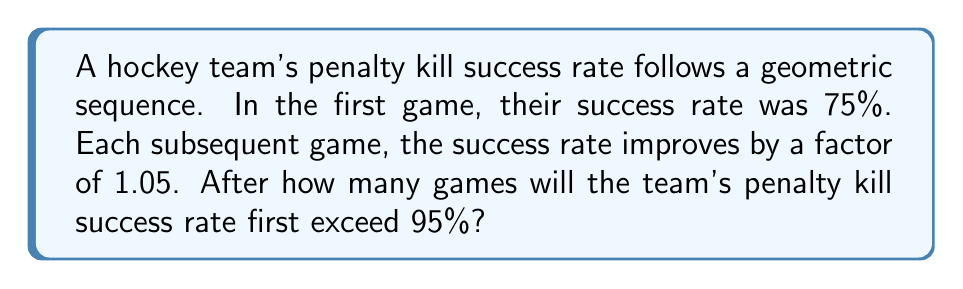Could you help me with this problem? Let's approach this step-by-step:

1) The initial success rate is 75% = 0.75
2) Each game, the rate is multiplied by 1.05

We can represent this as a geometric sequence:
$$ a_n = 0.75 \cdot (1.05)^{n-1} $$

Where $a_n$ is the success rate after n games.

3) We need to find n where $a_n > 0.95$

$$ 0.75 \cdot (1.05)^{n-1} > 0.95 $$

4) Divide both sides by 0.75:

$$ (1.05)^{n-1} > \frac{0.95}{0.75} = \frac{19}{15} $$

5) Take the natural log of both sides:

$$ (n-1) \cdot \ln(1.05) > \ln(\frac{19}{15}) $$

6) Solve for n:

$$ n > \frac{\ln(\frac{19}{15})}{\ln(1.05)} + 1 $$

7) Calculate:

$$ n > 10.67 $$

8) Since n must be a whole number of games, the first time the success rate exceeds 95% will be after the 11th game.
Answer: 11 games 